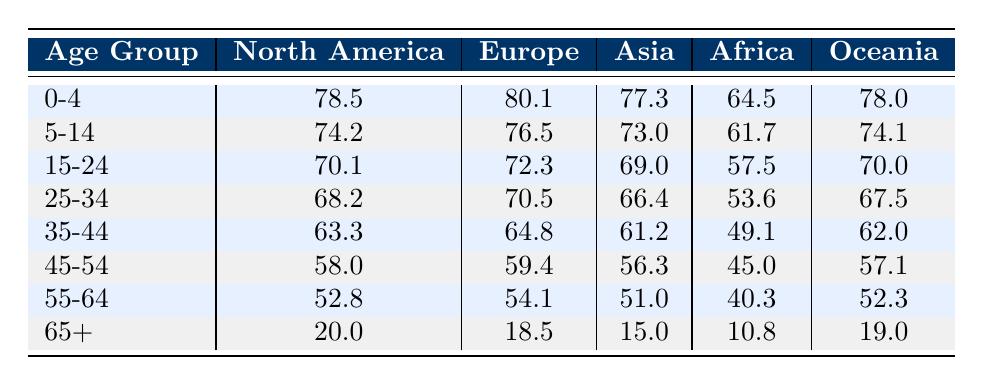What is the life expectancy for the age group 15-24 in Europe? The table shows that for the age group 15-24 in Europe, the life expectancy is listed as 72.3.
Answer: 72.3 Which region has the highest life expectancy for the age group 0-4? By comparing the values of life expectancy for the age group 0-4 across all regions, Europe has the highest at 80.1.
Answer: Europe What is the difference in life expectancy between the age groups 55-64 in Asia and Africa? For Asia, the life expectancy for the age group 55-64 is 51.0, while for Africa, it is 40.3. The difference is 51.0 - 40.3 = 10.7.
Answer: 10.7 Is the life expectancy for the age group 65+ in North America greater than that in Oceania? The life expectancy for North America in the age group 65+ is 20.0 and for Oceania, it is 19.0. Since 20.0 is greater than 19.0, the statement is true.
Answer: Yes What is the average life expectancy for the age group 45-54 across all regions? First, sum the life expectancies: 58.0 (North America) + 59.4 (Europe) + 56.3 (Asia) + 45.0 (Africa) + 57.1 (Oceania) = 276. Then, divide by the number of regions (5): 276 / 5 = 55.2.
Answer: 55.2 Which age group in Africa has the lowest life expectancy? Looking at the data for Africa across all age groups, the age group 65+ has the lowest life expectancy at 10.8.
Answer: 65+ Is the life expectancy for age group 25-34 in Europe higher than that in North America? The life expectancy for age group 25-34 in Europe is 70.5, while in North America it is 68.2. Since 70.5 is greater than 68.2, the statement is true.
Answer: Yes What is the sum of life expectancies for the age groups 5-14 and 15-24 in Asia? For Asia, the life expectancy for 5-14 is 73.0 and for 15-24 it is 69.0. The sum is 73.0 + 69.0 = 142.0.
Answer: 142.0 Which region has the lowest life expectancy for the age group 35-44? When comparing the life expectancies for age group 35-44 across all regions, Africa's life expectancy is the lowest at 49.1.
Answer: Africa 